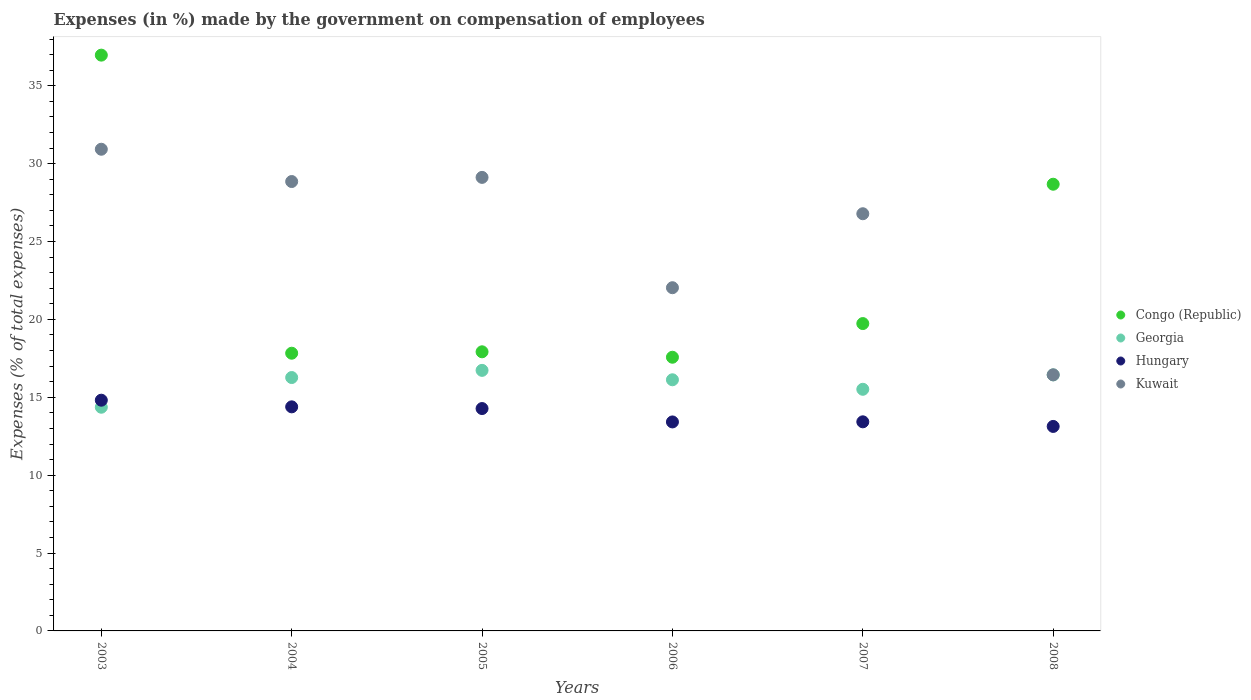Is the number of dotlines equal to the number of legend labels?
Provide a succinct answer. Yes. What is the percentage of expenses made by the government on compensation of employees in Kuwait in 2008?
Provide a short and direct response. 16.44. Across all years, what is the maximum percentage of expenses made by the government on compensation of employees in Congo (Republic)?
Make the answer very short. 36.97. Across all years, what is the minimum percentage of expenses made by the government on compensation of employees in Hungary?
Provide a short and direct response. 13.13. In which year was the percentage of expenses made by the government on compensation of employees in Congo (Republic) maximum?
Make the answer very short. 2003. In which year was the percentage of expenses made by the government on compensation of employees in Congo (Republic) minimum?
Offer a very short reply. 2006. What is the total percentage of expenses made by the government on compensation of employees in Hungary in the graph?
Make the answer very short. 83.45. What is the difference between the percentage of expenses made by the government on compensation of employees in Kuwait in 2004 and that in 2008?
Ensure brevity in your answer.  12.41. What is the difference between the percentage of expenses made by the government on compensation of employees in Congo (Republic) in 2005 and the percentage of expenses made by the government on compensation of employees in Georgia in 2007?
Your answer should be very brief. 2.41. What is the average percentage of expenses made by the government on compensation of employees in Georgia per year?
Offer a very short reply. 15.91. In the year 2007, what is the difference between the percentage of expenses made by the government on compensation of employees in Georgia and percentage of expenses made by the government on compensation of employees in Congo (Republic)?
Keep it short and to the point. -4.22. In how many years, is the percentage of expenses made by the government on compensation of employees in Congo (Republic) greater than 29 %?
Provide a short and direct response. 1. What is the ratio of the percentage of expenses made by the government on compensation of employees in Kuwait in 2005 to that in 2007?
Your answer should be very brief. 1.09. What is the difference between the highest and the second highest percentage of expenses made by the government on compensation of employees in Congo (Republic)?
Ensure brevity in your answer.  8.29. What is the difference between the highest and the lowest percentage of expenses made by the government on compensation of employees in Congo (Republic)?
Offer a very short reply. 19.4. Does the percentage of expenses made by the government on compensation of employees in Kuwait monotonically increase over the years?
Offer a terse response. No. Is the percentage of expenses made by the government on compensation of employees in Hungary strictly greater than the percentage of expenses made by the government on compensation of employees in Kuwait over the years?
Provide a succinct answer. No. How many dotlines are there?
Your response must be concise. 4. Does the graph contain any zero values?
Give a very brief answer. No. Where does the legend appear in the graph?
Make the answer very short. Center right. How are the legend labels stacked?
Your answer should be compact. Vertical. What is the title of the graph?
Keep it short and to the point. Expenses (in %) made by the government on compensation of employees. What is the label or title of the Y-axis?
Give a very brief answer. Expenses (% of total expenses). What is the Expenses (% of total expenses) of Congo (Republic) in 2003?
Your response must be concise. 36.97. What is the Expenses (% of total expenses) of Georgia in 2003?
Offer a terse response. 14.36. What is the Expenses (% of total expenses) in Hungary in 2003?
Ensure brevity in your answer.  14.81. What is the Expenses (% of total expenses) in Kuwait in 2003?
Give a very brief answer. 30.93. What is the Expenses (% of total expenses) in Congo (Republic) in 2004?
Your response must be concise. 17.83. What is the Expenses (% of total expenses) in Georgia in 2004?
Ensure brevity in your answer.  16.27. What is the Expenses (% of total expenses) of Hungary in 2004?
Make the answer very short. 14.39. What is the Expenses (% of total expenses) of Kuwait in 2004?
Your response must be concise. 28.85. What is the Expenses (% of total expenses) of Congo (Republic) in 2005?
Your answer should be very brief. 17.92. What is the Expenses (% of total expenses) of Georgia in 2005?
Give a very brief answer. 16.73. What is the Expenses (% of total expenses) in Hungary in 2005?
Provide a short and direct response. 14.28. What is the Expenses (% of total expenses) in Kuwait in 2005?
Your answer should be compact. 29.12. What is the Expenses (% of total expenses) in Congo (Republic) in 2006?
Provide a short and direct response. 17.57. What is the Expenses (% of total expenses) of Georgia in 2006?
Offer a very short reply. 16.12. What is the Expenses (% of total expenses) in Hungary in 2006?
Offer a very short reply. 13.42. What is the Expenses (% of total expenses) of Kuwait in 2006?
Give a very brief answer. 22.04. What is the Expenses (% of total expenses) in Congo (Republic) in 2007?
Your answer should be very brief. 19.73. What is the Expenses (% of total expenses) of Georgia in 2007?
Keep it short and to the point. 15.51. What is the Expenses (% of total expenses) in Hungary in 2007?
Give a very brief answer. 13.43. What is the Expenses (% of total expenses) in Kuwait in 2007?
Your answer should be very brief. 26.79. What is the Expenses (% of total expenses) of Congo (Republic) in 2008?
Your response must be concise. 28.68. What is the Expenses (% of total expenses) of Georgia in 2008?
Offer a terse response. 16.44. What is the Expenses (% of total expenses) in Hungary in 2008?
Offer a terse response. 13.13. What is the Expenses (% of total expenses) in Kuwait in 2008?
Your answer should be very brief. 16.44. Across all years, what is the maximum Expenses (% of total expenses) in Congo (Republic)?
Your answer should be very brief. 36.97. Across all years, what is the maximum Expenses (% of total expenses) of Georgia?
Offer a very short reply. 16.73. Across all years, what is the maximum Expenses (% of total expenses) of Hungary?
Provide a succinct answer. 14.81. Across all years, what is the maximum Expenses (% of total expenses) of Kuwait?
Offer a very short reply. 30.93. Across all years, what is the minimum Expenses (% of total expenses) in Congo (Republic)?
Provide a short and direct response. 17.57. Across all years, what is the minimum Expenses (% of total expenses) of Georgia?
Provide a succinct answer. 14.36. Across all years, what is the minimum Expenses (% of total expenses) in Hungary?
Your answer should be very brief. 13.13. Across all years, what is the minimum Expenses (% of total expenses) of Kuwait?
Ensure brevity in your answer.  16.44. What is the total Expenses (% of total expenses) of Congo (Republic) in the graph?
Your answer should be very brief. 138.71. What is the total Expenses (% of total expenses) in Georgia in the graph?
Make the answer very short. 95.44. What is the total Expenses (% of total expenses) of Hungary in the graph?
Provide a short and direct response. 83.45. What is the total Expenses (% of total expenses) in Kuwait in the graph?
Provide a succinct answer. 154.16. What is the difference between the Expenses (% of total expenses) in Congo (Republic) in 2003 and that in 2004?
Give a very brief answer. 19.14. What is the difference between the Expenses (% of total expenses) in Georgia in 2003 and that in 2004?
Your response must be concise. -1.91. What is the difference between the Expenses (% of total expenses) in Hungary in 2003 and that in 2004?
Offer a terse response. 0.43. What is the difference between the Expenses (% of total expenses) in Kuwait in 2003 and that in 2004?
Offer a terse response. 2.07. What is the difference between the Expenses (% of total expenses) in Congo (Republic) in 2003 and that in 2005?
Provide a short and direct response. 19.05. What is the difference between the Expenses (% of total expenses) of Georgia in 2003 and that in 2005?
Your answer should be compact. -2.37. What is the difference between the Expenses (% of total expenses) in Hungary in 2003 and that in 2005?
Your answer should be compact. 0.54. What is the difference between the Expenses (% of total expenses) of Kuwait in 2003 and that in 2005?
Your answer should be compact. 1.81. What is the difference between the Expenses (% of total expenses) of Congo (Republic) in 2003 and that in 2006?
Make the answer very short. 19.4. What is the difference between the Expenses (% of total expenses) of Georgia in 2003 and that in 2006?
Your response must be concise. -1.76. What is the difference between the Expenses (% of total expenses) of Hungary in 2003 and that in 2006?
Make the answer very short. 1.4. What is the difference between the Expenses (% of total expenses) in Kuwait in 2003 and that in 2006?
Your answer should be compact. 8.89. What is the difference between the Expenses (% of total expenses) of Congo (Republic) in 2003 and that in 2007?
Ensure brevity in your answer.  17.23. What is the difference between the Expenses (% of total expenses) of Georgia in 2003 and that in 2007?
Make the answer very short. -1.15. What is the difference between the Expenses (% of total expenses) in Hungary in 2003 and that in 2007?
Provide a succinct answer. 1.39. What is the difference between the Expenses (% of total expenses) of Kuwait in 2003 and that in 2007?
Keep it short and to the point. 4.14. What is the difference between the Expenses (% of total expenses) in Congo (Republic) in 2003 and that in 2008?
Your answer should be compact. 8.29. What is the difference between the Expenses (% of total expenses) of Georgia in 2003 and that in 2008?
Keep it short and to the point. -2.08. What is the difference between the Expenses (% of total expenses) in Hungary in 2003 and that in 2008?
Offer a very short reply. 1.68. What is the difference between the Expenses (% of total expenses) of Kuwait in 2003 and that in 2008?
Provide a short and direct response. 14.48. What is the difference between the Expenses (% of total expenses) in Congo (Republic) in 2004 and that in 2005?
Offer a very short reply. -0.09. What is the difference between the Expenses (% of total expenses) of Georgia in 2004 and that in 2005?
Offer a terse response. -0.46. What is the difference between the Expenses (% of total expenses) of Hungary in 2004 and that in 2005?
Keep it short and to the point. 0.11. What is the difference between the Expenses (% of total expenses) in Kuwait in 2004 and that in 2005?
Your answer should be compact. -0.27. What is the difference between the Expenses (% of total expenses) of Congo (Republic) in 2004 and that in 2006?
Provide a succinct answer. 0.26. What is the difference between the Expenses (% of total expenses) of Georgia in 2004 and that in 2006?
Provide a succinct answer. 0.14. What is the difference between the Expenses (% of total expenses) in Hungary in 2004 and that in 2006?
Ensure brevity in your answer.  0.97. What is the difference between the Expenses (% of total expenses) of Kuwait in 2004 and that in 2006?
Provide a succinct answer. 6.82. What is the difference between the Expenses (% of total expenses) of Congo (Republic) in 2004 and that in 2007?
Give a very brief answer. -1.9. What is the difference between the Expenses (% of total expenses) of Georgia in 2004 and that in 2007?
Provide a succinct answer. 0.75. What is the difference between the Expenses (% of total expenses) in Hungary in 2004 and that in 2007?
Your response must be concise. 0.96. What is the difference between the Expenses (% of total expenses) of Kuwait in 2004 and that in 2007?
Provide a short and direct response. 2.07. What is the difference between the Expenses (% of total expenses) of Congo (Republic) in 2004 and that in 2008?
Provide a succinct answer. -10.85. What is the difference between the Expenses (% of total expenses) in Georgia in 2004 and that in 2008?
Make the answer very short. -0.17. What is the difference between the Expenses (% of total expenses) of Hungary in 2004 and that in 2008?
Keep it short and to the point. 1.26. What is the difference between the Expenses (% of total expenses) in Kuwait in 2004 and that in 2008?
Keep it short and to the point. 12.41. What is the difference between the Expenses (% of total expenses) in Congo (Republic) in 2005 and that in 2006?
Your answer should be very brief. 0.35. What is the difference between the Expenses (% of total expenses) in Georgia in 2005 and that in 2006?
Give a very brief answer. 0.6. What is the difference between the Expenses (% of total expenses) of Hungary in 2005 and that in 2006?
Offer a terse response. 0.86. What is the difference between the Expenses (% of total expenses) of Kuwait in 2005 and that in 2006?
Ensure brevity in your answer.  7.08. What is the difference between the Expenses (% of total expenses) in Congo (Republic) in 2005 and that in 2007?
Ensure brevity in your answer.  -1.81. What is the difference between the Expenses (% of total expenses) of Georgia in 2005 and that in 2007?
Give a very brief answer. 1.21. What is the difference between the Expenses (% of total expenses) in Hungary in 2005 and that in 2007?
Your response must be concise. 0.85. What is the difference between the Expenses (% of total expenses) of Kuwait in 2005 and that in 2007?
Your response must be concise. 2.33. What is the difference between the Expenses (% of total expenses) in Congo (Republic) in 2005 and that in 2008?
Ensure brevity in your answer.  -10.76. What is the difference between the Expenses (% of total expenses) of Georgia in 2005 and that in 2008?
Make the answer very short. 0.29. What is the difference between the Expenses (% of total expenses) in Hungary in 2005 and that in 2008?
Keep it short and to the point. 1.15. What is the difference between the Expenses (% of total expenses) in Kuwait in 2005 and that in 2008?
Give a very brief answer. 12.68. What is the difference between the Expenses (% of total expenses) in Congo (Republic) in 2006 and that in 2007?
Keep it short and to the point. -2.16. What is the difference between the Expenses (% of total expenses) of Georgia in 2006 and that in 2007?
Provide a short and direct response. 0.61. What is the difference between the Expenses (% of total expenses) in Hungary in 2006 and that in 2007?
Your response must be concise. -0.01. What is the difference between the Expenses (% of total expenses) in Kuwait in 2006 and that in 2007?
Keep it short and to the point. -4.75. What is the difference between the Expenses (% of total expenses) of Congo (Republic) in 2006 and that in 2008?
Your response must be concise. -11.11. What is the difference between the Expenses (% of total expenses) of Georgia in 2006 and that in 2008?
Your answer should be compact. -0.31. What is the difference between the Expenses (% of total expenses) of Hungary in 2006 and that in 2008?
Offer a terse response. 0.29. What is the difference between the Expenses (% of total expenses) in Kuwait in 2006 and that in 2008?
Your answer should be very brief. 5.59. What is the difference between the Expenses (% of total expenses) of Congo (Republic) in 2007 and that in 2008?
Ensure brevity in your answer.  -8.95. What is the difference between the Expenses (% of total expenses) of Georgia in 2007 and that in 2008?
Ensure brevity in your answer.  -0.92. What is the difference between the Expenses (% of total expenses) in Hungary in 2007 and that in 2008?
Keep it short and to the point. 0.3. What is the difference between the Expenses (% of total expenses) in Kuwait in 2007 and that in 2008?
Give a very brief answer. 10.34. What is the difference between the Expenses (% of total expenses) of Congo (Republic) in 2003 and the Expenses (% of total expenses) of Georgia in 2004?
Offer a terse response. 20.7. What is the difference between the Expenses (% of total expenses) in Congo (Republic) in 2003 and the Expenses (% of total expenses) in Hungary in 2004?
Your answer should be compact. 22.58. What is the difference between the Expenses (% of total expenses) in Congo (Republic) in 2003 and the Expenses (% of total expenses) in Kuwait in 2004?
Your answer should be compact. 8.12. What is the difference between the Expenses (% of total expenses) in Georgia in 2003 and the Expenses (% of total expenses) in Hungary in 2004?
Your answer should be compact. -0.02. What is the difference between the Expenses (% of total expenses) of Georgia in 2003 and the Expenses (% of total expenses) of Kuwait in 2004?
Offer a terse response. -14.49. What is the difference between the Expenses (% of total expenses) in Hungary in 2003 and the Expenses (% of total expenses) in Kuwait in 2004?
Keep it short and to the point. -14.04. What is the difference between the Expenses (% of total expenses) in Congo (Republic) in 2003 and the Expenses (% of total expenses) in Georgia in 2005?
Your answer should be compact. 20.24. What is the difference between the Expenses (% of total expenses) of Congo (Republic) in 2003 and the Expenses (% of total expenses) of Hungary in 2005?
Provide a short and direct response. 22.69. What is the difference between the Expenses (% of total expenses) of Congo (Republic) in 2003 and the Expenses (% of total expenses) of Kuwait in 2005?
Your answer should be very brief. 7.85. What is the difference between the Expenses (% of total expenses) in Georgia in 2003 and the Expenses (% of total expenses) in Hungary in 2005?
Your answer should be very brief. 0.08. What is the difference between the Expenses (% of total expenses) of Georgia in 2003 and the Expenses (% of total expenses) of Kuwait in 2005?
Your answer should be very brief. -14.76. What is the difference between the Expenses (% of total expenses) of Hungary in 2003 and the Expenses (% of total expenses) of Kuwait in 2005?
Ensure brevity in your answer.  -14.31. What is the difference between the Expenses (% of total expenses) of Congo (Republic) in 2003 and the Expenses (% of total expenses) of Georgia in 2006?
Provide a succinct answer. 20.84. What is the difference between the Expenses (% of total expenses) in Congo (Republic) in 2003 and the Expenses (% of total expenses) in Hungary in 2006?
Offer a very short reply. 23.55. What is the difference between the Expenses (% of total expenses) of Congo (Republic) in 2003 and the Expenses (% of total expenses) of Kuwait in 2006?
Keep it short and to the point. 14.93. What is the difference between the Expenses (% of total expenses) of Georgia in 2003 and the Expenses (% of total expenses) of Hungary in 2006?
Give a very brief answer. 0.94. What is the difference between the Expenses (% of total expenses) of Georgia in 2003 and the Expenses (% of total expenses) of Kuwait in 2006?
Your response must be concise. -7.67. What is the difference between the Expenses (% of total expenses) of Hungary in 2003 and the Expenses (% of total expenses) of Kuwait in 2006?
Offer a very short reply. -7.22. What is the difference between the Expenses (% of total expenses) of Congo (Republic) in 2003 and the Expenses (% of total expenses) of Georgia in 2007?
Provide a succinct answer. 21.45. What is the difference between the Expenses (% of total expenses) in Congo (Republic) in 2003 and the Expenses (% of total expenses) in Hungary in 2007?
Provide a short and direct response. 23.54. What is the difference between the Expenses (% of total expenses) in Congo (Republic) in 2003 and the Expenses (% of total expenses) in Kuwait in 2007?
Your response must be concise. 10.18. What is the difference between the Expenses (% of total expenses) of Georgia in 2003 and the Expenses (% of total expenses) of Hungary in 2007?
Ensure brevity in your answer.  0.94. What is the difference between the Expenses (% of total expenses) in Georgia in 2003 and the Expenses (% of total expenses) in Kuwait in 2007?
Your answer should be compact. -12.42. What is the difference between the Expenses (% of total expenses) in Hungary in 2003 and the Expenses (% of total expenses) in Kuwait in 2007?
Offer a terse response. -11.97. What is the difference between the Expenses (% of total expenses) in Congo (Republic) in 2003 and the Expenses (% of total expenses) in Georgia in 2008?
Make the answer very short. 20.53. What is the difference between the Expenses (% of total expenses) in Congo (Republic) in 2003 and the Expenses (% of total expenses) in Hungary in 2008?
Offer a very short reply. 23.84. What is the difference between the Expenses (% of total expenses) of Congo (Republic) in 2003 and the Expenses (% of total expenses) of Kuwait in 2008?
Your answer should be very brief. 20.53. What is the difference between the Expenses (% of total expenses) of Georgia in 2003 and the Expenses (% of total expenses) of Hungary in 2008?
Keep it short and to the point. 1.23. What is the difference between the Expenses (% of total expenses) of Georgia in 2003 and the Expenses (% of total expenses) of Kuwait in 2008?
Offer a terse response. -2.08. What is the difference between the Expenses (% of total expenses) in Hungary in 2003 and the Expenses (% of total expenses) in Kuwait in 2008?
Your answer should be compact. -1.63. What is the difference between the Expenses (% of total expenses) in Congo (Republic) in 2004 and the Expenses (% of total expenses) in Georgia in 2005?
Offer a terse response. 1.1. What is the difference between the Expenses (% of total expenses) of Congo (Republic) in 2004 and the Expenses (% of total expenses) of Hungary in 2005?
Your answer should be compact. 3.55. What is the difference between the Expenses (% of total expenses) in Congo (Republic) in 2004 and the Expenses (% of total expenses) in Kuwait in 2005?
Keep it short and to the point. -11.29. What is the difference between the Expenses (% of total expenses) of Georgia in 2004 and the Expenses (% of total expenses) of Hungary in 2005?
Keep it short and to the point. 1.99. What is the difference between the Expenses (% of total expenses) of Georgia in 2004 and the Expenses (% of total expenses) of Kuwait in 2005?
Your answer should be very brief. -12.85. What is the difference between the Expenses (% of total expenses) of Hungary in 2004 and the Expenses (% of total expenses) of Kuwait in 2005?
Make the answer very short. -14.73. What is the difference between the Expenses (% of total expenses) of Congo (Republic) in 2004 and the Expenses (% of total expenses) of Georgia in 2006?
Offer a very short reply. 1.71. What is the difference between the Expenses (% of total expenses) in Congo (Republic) in 2004 and the Expenses (% of total expenses) in Hungary in 2006?
Ensure brevity in your answer.  4.41. What is the difference between the Expenses (% of total expenses) in Congo (Republic) in 2004 and the Expenses (% of total expenses) in Kuwait in 2006?
Provide a short and direct response. -4.21. What is the difference between the Expenses (% of total expenses) in Georgia in 2004 and the Expenses (% of total expenses) in Hungary in 2006?
Offer a terse response. 2.85. What is the difference between the Expenses (% of total expenses) in Georgia in 2004 and the Expenses (% of total expenses) in Kuwait in 2006?
Give a very brief answer. -5.77. What is the difference between the Expenses (% of total expenses) in Hungary in 2004 and the Expenses (% of total expenses) in Kuwait in 2006?
Make the answer very short. -7.65. What is the difference between the Expenses (% of total expenses) in Congo (Republic) in 2004 and the Expenses (% of total expenses) in Georgia in 2007?
Your response must be concise. 2.32. What is the difference between the Expenses (% of total expenses) of Congo (Republic) in 2004 and the Expenses (% of total expenses) of Hungary in 2007?
Offer a very short reply. 4.4. What is the difference between the Expenses (% of total expenses) of Congo (Republic) in 2004 and the Expenses (% of total expenses) of Kuwait in 2007?
Keep it short and to the point. -8.96. What is the difference between the Expenses (% of total expenses) of Georgia in 2004 and the Expenses (% of total expenses) of Hungary in 2007?
Provide a succinct answer. 2.84. What is the difference between the Expenses (% of total expenses) in Georgia in 2004 and the Expenses (% of total expenses) in Kuwait in 2007?
Provide a short and direct response. -10.52. What is the difference between the Expenses (% of total expenses) of Hungary in 2004 and the Expenses (% of total expenses) of Kuwait in 2007?
Keep it short and to the point. -12.4. What is the difference between the Expenses (% of total expenses) of Congo (Republic) in 2004 and the Expenses (% of total expenses) of Georgia in 2008?
Your answer should be very brief. 1.39. What is the difference between the Expenses (% of total expenses) in Congo (Republic) in 2004 and the Expenses (% of total expenses) in Hungary in 2008?
Offer a terse response. 4.7. What is the difference between the Expenses (% of total expenses) of Congo (Republic) in 2004 and the Expenses (% of total expenses) of Kuwait in 2008?
Provide a succinct answer. 1.39. What is the difference between the Expenses (% of total expenses) in Georgia in 2004 and the Expenses (% of total expenses) in Hungary in 2008?
Keep it short and to the point. 3.14. What is the difference between the Expenses (% of total expenses) of Georgia in 2004 and the Expenses (% of total expenses) of Kuwait in 2008?
Offer a terse response. -0.17. What is the difference between the Expenses (% of total expenses) in Hungary in 2004 and the Expenses (% of total expenses) in Kuwait in 2008?
Your answer should be very brief. -2.06. What is the difference between the Expenses (% of total expenses) in Congo (Republic) in 2005 and the Expenses (% of total expenses) in Georgia in 2006?
Your response must be concise. 1.8. What is the difference between the Expenses (% of total expenses) in Congo (Republic) in 2005 and the Expenses (% of total expenses) in Hungary in 2006?
Provide a succinct answer. 4.5. What is the difference between the Expenses (% of total expenses) of Congo (Republic) in 2005 and the Expenses (% of total expenses) of Kuwait in 2006?
Give a very brief answer. -4.11. What is the difference between the Expenses (% of total expenses) of Georgia in 2005 and the Expenses (% of total expenses) of Hungary in 2006?
Keep it short and to the point. 3.31. What is the difference between the Expenses (% of total expenses) in Georgia in 2005 and the Expenses (% of total expenses) in Kuwait in 2006?
Your response must be concise. -5.31. What is the difference between the Expenses (% of total expenses) in Hungary in 2005 and the Expenses (% of total expenses) in Kuwait in 2006?
Provide a succinct answer. -7.76. What is the difference between the Expenses (% of total expenses) of Congo (Republic) in 2005 and the Expenses (% of total expenses) of Georgia in 2007?
Provide a short and direct response. 2.41. What is the difference between the Expenses (% of total expenses) of Congo (Republic) in 2005 and the Expenses (% of total expenses) of Hungary in 2007?
Give a very brief answer. 4.5. What is the difference between the Expenses (% of total expenses) of Congo (Republic) in 2005 and the Expenses (% of total expenses) of Kuwait in 2007?
Your response must be concise. -8.86. What is the difference between the Expenses (% of total expenses) in Georgia in 2005 and the Expenses (% of total expenses) in Hungary in 2007?
Ensure brevity in your answer.  3.3. What is the difference between the Expenses (% of total expenses) of Georgia in 2005 and the Expenses (% of total expenses) of Kuwait in 2007?
Offer a very short reply. -10.06. What is the difference between the Expenses (% of total expenses) in Hungary in 2005 and the Expenses (% of total expenses) in Kuwait in 2007?
Your answer should be very brief. -12.51. What is the difference between the Expenses (% of total expenses) in Congo (Republic) in 2005 and the Expenses (% of total expenses) in Georgia in 2008?
Give a very brief answer. 1.48. What is the difference between the Expenses (% of total expenses) in Congo (Republic) in 2005 and the Expenses (% of total expenses) in Hungary in 2008?
Ensure brevity in your answer.  4.79. What is the difference between the Expenses (% of total expenses) of Congo (Republic) in 2005 and the Expenses (% of total expenses) of Kuwait in 2008?
Offer a very short reply. 1.48. What is the difference between the Expenses (% of total expenses) of Georgia in 2005 and the Expenses (% of total expenses) of Hungary in 2008?
Your response must be concise. 3.6. What is the difference between the Expenses (% of total expenses) of Georgia in 2005 and the Expenses (% of total expenses) of Kuwait in 2008?
Offer a very short reply. 0.29. What is the difference between the Expenses (% of total expenses) in Hungary in 2005 and the Expenses (% of total expenses) in Kuwait in 2008?
Your response must be concise. -2.17. What is the difference between the Expenses (% of total expenses) of Congo (Republic) in 2006 and the Expenses (% of total expenses) of Georgia in 2007?
Keep it short and to the point. 2.06. What is the difference between the Expenses (% of total expenses) in Congo (Republic) in 2006 and the Expenses (% of total expenses) in Hungary in 2007?
Your response must be concise. 4.15. What is the difference between the Expenses (% of total expenses) of Congo (Republic) in 2006 and the Expenses (% of total expenses) of Kuwait in 2007?
Your answer should be very brief. -9.21. What is the difference between the Expenses (% of total expenses) of Georgia in 2006 and the Expenses (% of total expenses) of Hungary in 2007?
Offer a terse response. 2.7. What is the difference between the Expenses (% of total expenses) in Georgia in 2006 and the Expenses (% of total expenses) in Kuwait in 2007?
Offer a terse response. -10.66. What is the difference between the Expenses (% of total expenses) of Hungary in 2006 and the Expenses (% of total expenses) of Kuwait in 2007?
Give a very brief answer. -13.37. What is the difference between the Expenses (% of total expenses) in Congo (Republic) in 2006 and the Expenses (% of total expenses) in Georgia in 2008?
Ensure brevity in your answer.  1.13. What is the difference between the Expenses (% of total expenses) in Congo (Republic) in 2006 and the Expenses (% of total expenses) in Hungary in 2008?
Give a very brief answer. 4.44. What is the difference between the Expenses (% of total expenses) of Congo (Republic) in 2006 and the Expenses (% of total expenses) of Kuwait in 2008?
Your answer should be very brief. 1.13. What is the difference between the Expenses (% of total expenses) of Georgia in 2006 and the Expenses (% of total expenses) of Hungary in 2008?
Ensure brevity in your answer.  2.99. What is the difference between the Expenses (% of total expenses) in Georgia in 2006 and the Expenses (% of total expenses) in Kuwait in 2008?
Make the answer very short. -0.32. What is the difference between the Expenses (% of total expenses) in Hungary in 2006 and the Expenses (% of total expenses) in Kuwait in 2008?
Offer a terse response. -3.03. What is the difference between the Expenses (% of total expenses) in Congo (Republic) in 2007 and the Expenses (% of total expenses) in Georgia in 2008?
Provide a short and direct response. 3.3. What is the difference between the Expenses (% of total expenses) of Congo (Republic) in 2007 and the Expenses (% of total expenses) of Hungary in 2008?
Offer a very short reply. 6.6. What is the difference between the Expenses (% of total expenses) in Congo (Republic) in 2007 and the Expenses (% of total expenses) in Kuwait in 2008?
Provide a short and direct response. 3.29. What is the difference between the Expenses (% of total expenses) of Georgia in 2007 and the Expenses (% of total expenses) of Hungary in 2008?
Keep it short and to the point. 2.38. What is the difference between the Expenses (% of total expenses) of Georgia in 2007 and the Expenses (% of total expenses) of Kuwait in 2008?
Give a very brief answer. -0.93. What is the difference between the Expenses (% of total expenses) in Hungary in 2007 and the Expenses (% of total expenses) in Kuwait in 2008?
Give a very brief answer. -3.02. What is the average Expenses (% of total expenses) in Congo (Republic) per year?
Your answer should be very brief. 23.12. What is the average Expenses (% of total expenses) in Georgia per year?
Provide a succinct answer. 15.91. What is the average Expenses (% of total expenses) of Hungary per year?
Keep it short and to the point. 13.91. What is the average Expenses (% of total expenses) of Kuwait per year?
Provide a short and direct response. 25.69. In the year 2003, what is the difference between the Expenses (% of total expenses) in Congo (Republic) and Expenses (% of total expenses) in Georgia?
Your answer should be very brief. 22.61. In the year 2003, what is the difference between the Expenses (% of total expenses) of Congo (Republic) and Expenses (% of total expenses) of Hungary?
Give a very brief answer. 22.15. In the year 2003, what is the difference between the Expenses (% of total expenses) in Congo (Republic) and Expenses (% of total expenses) in Kuwait?
Keep it short and to the point. 6.04. In the year 2003, what is the difference between the Expenses (% of total expenses) in Georgia and Expenses (% of total expenses) in Hungary?
Your answer should be compact. -0.45. In the year 2003, what is the difference between the Expenses (% of total expenses) of Georgia and Expenses (% of total expenses) of Kuwait?
Offer a very short reply. -16.56. In the year 2003, what is the difference between the Expenses (% of total expenses) of Hungary and Expenses (% of total expenses) of Kuwait?
Your answer should be compact. -16.11. In the year 2004, what is the difference between the Expenses (% of total expenses) of Congo (Republic) and Expenses (% of total expenses) of Georgia?
Provide a short and direct response. 1.56. In the year 2004, what is the difference between the Expenses (% of total expenses) of Congo (Republic) and Expenses (% of total expenses) of Hungary?
Provide a succinct answer. 3.44. In the year 2004, what is the difference between the Expenses (% of total expenses) in Congo (Republic) and Expenses (% of total expenses) in Kuwait?
Ensure brevity in your answer.  -11.02. In the year 2004, what is the difference between the Expenses (% of total expenses) in Georgia and Expenses (% of total expenses) in Hungary?
Your answer should be compact. 1.88. In the year 2004, what is the difference between the Expenses (% of total expenses) in Georgia and Expenses (% of total expenses) in Kuwait?
Keep it short and to the point. -12.58. In the year 2004, what is the difference between the Expenses (% of total expenses) in Hungary and Expenses (% of total expenses) in Kuwait?
Your response must be concise. -14.47. In the year 2005, what is the difference between the Expenses (% of total expenses) in Congo (Republic) and Expenses (% of total expenses) in Georgia?
Ensure brevity in your answer.  1.19. In the year 2005, what is the difference between the Expenses (% of total expenses) of Congo (Republic) and Expenses (% of total expenses) of Hungary?
Make the answer very short. 3.64. In the year 2005, what is the difference between the Expenses (% of total expenses) of Congo (Republic) and Expenses (% of total expenses) of Kuwait?
Your response must be concise. -11.2. In the year 2005, what is the difference between the Expenses (% of total expenses) of Georgia and Expenses (% of total expenses) of Hungary?
Provide a short and direct response. 2.45. In the year 2005, what is the difference between the Expenses (% of total expenses) of Georgia and Expenses (% of total expenses) of Kuwait?
Provide a short and direct response. -12.39. In the year 2005, what is the difference between the Expenses (% of total expenses) in Hungary and Expenses (% of total expenses) in Kuwait?
Your answer should be compact. -14.84. In the year 2006, what is the difference between the Expenses (% of total expenses) in Congo (Republic) and Expenses (% of total expenses) in Georgia?
Keep it short and to the point. 1.45. In the year 2006, what is the difference between the Expenses (% of total expenses) in Congo (Republic) and Expenses (% of total expenses) in Hungary?
Provide a short and direct response. 4.15. In the year 2006, what is the difference between the Expenses (% of total expenses) of Congo (Republic) and Expenses (% of total expenses) of Kuwait?
Give a very brief answer. -4.46. In the year 2006, what is the difference between the Expenses (% of total expenses) in Georgia and Expenses (% of total expenses) in Hungary?
Ensure brevity in your answer.  2.71. In the year 2006, what is the difference between the Expenses (% of total expenses) in Georgia and Expenses (% of total expenses) in Kuwait?
Provide a succinct answer. -5.91. In the year 2006, what is the difference between the Expenses (% of total expenses) in Hungary and Expenses (% of total expenses) in Kuwait?
Keep it short and to the point. -8.62. In the year 2007, what is the difference between the Expenses (% of total expenses) of Congo (Republic) and Expenses (% of total expenses) of Georgia?
Give a very brief answer. 4.22. In the year 2007, what is the difference between the Expenses (% of total expenses) in Congo (Republic) and Expenses (% of total expenses) in Hungary?
Your answer should be very brief. 6.31. In the year 2007, what is the difference between the Expenses (% of total expenses) in Congo (Republic) and Expenses (% of total expenses) in Kuwait?
Give a very brief answer. -7.05. In the year 2007, what is the difference between the Expenses (% of total expenses) in Georgia and Expenses (% of total expenses) in Hungary?
Keep it short and to the point. 2.09. In the year 2007, what is the difference between the Expenses (% of total expenses) in Georgia and Expenses (% of total expenses) in Kuwait?
Your answer should be very brief. -11.27. In the year 2007, what is the difference between the Expenses (% of total expenses) of Hungary and Expenses (% of total expenses) of Kuwait?
Provide a short and direct response. -13.36. In the year 2008, what is the difference between the Expenses (% of total expenses) in Congo (Republic) and Expenses (% of total expenses) in Georgia?
Offer a terse response. 12.24. In the year 2008, what is the difference between the Expenses (% of total expenses) of Congo (Republic) and Expenses (% of total expenses) of Hungary?
Your answer should be compact. 15.55. In the year 2008, what is the difference between the Expenses (% of total expenses) of Congo (Republic) and Expenses (% of total expenses) of Kuwait?
Provide a succinct answer. 12.24. In the year 2008, what is the difference between the Expenses (% of total expenses) of Georgia and Expenses (% of total expenses) of Hungary?
Your answer should be very brief. 3.31. In the year 2008, what is the difference between the Expenses (% of total expenses) in Georgia and Expenses (% of total expenses) in Kuwait?
Ensure brevity in your answer.  -0. In the year 2008, what is the difference between the Expenses (% of total expenses) in Hungary and Expenses (% of total expenses) in Kuwait?
Make the answer very short. -3.31. What is the ratio of the Expenses (% of total expenses) of Congo (Republic) in 2003 to that in 2004?
Provide a short and direct response. 2.07. What is the ratio of the Expenses (% of total expenses) of Georgia in 2003 to that in 2004?
Give a very brief answer. 0.88. What is the ratio of the Expenses (% of total expenses) of Hungary in 2003 to that in 2004?
Your answer should be compact. 1.03. What is the ratio of the Expenses (% of total expenses) of Kuwait in 2003 to that in 2004?
Provide a succinct answer. 1.07. What is the ratio of the Expenses (% of total expenses) of Congo (Republic) in 2003 to that in 2005?
Offer a very short reply. 2.06. What is the ratio of the Expenses (% of total expenses) in Georgia in 2003 to that in 2005?
Ensure brevity in your answer.  0.86. What is the ratio of the Expenses (% of total expenses) of Hungary in 2003 to that in 2005?
Give a very brief answer. 1.04. What is the ratio of the Expenses (% of total expenses) in Kuwait in 2003 to that in 2005?
Provide a succinct answer. 1.06. What is the ratio of the Expenses (% of total expenses) of Congo (Republic) in 2003 to that in 2006?
Offer a terse response. 2.1. What is the ratio of the Expenses (% of total expenses) of Georgia in 2003 to that in 2006?
Provide a succinct answer. 0.89. What is the ratio of the Expenses (% of total expenses) of Hungary in 2003 to that in 2006?
Your answer should be very brief. 1.1. What is the ratio of the Expenses (% of total expenses) in Kuwait in 2003 to that in 2006?
Give a very brief answer. 1.4. What is the ratio of the Expenses (% of total expenses) in Congo (Republic) in 2003 to that in 2007?
Your response must be concise. 1.87. What is the ratio of the Expenses (% of total expenses) of Georgia in 2003 to that in 2007?
Offer a very short reply. 0.93. What is the ratio of the Expenses (% of total expenses) in Hungary in 2003 to that in 2007?
Your response must be concise. 1.1. What is the ratio of the Expenses (% of total expenses) in Kuwait in 2003 to that in 2007?
Offer a terse response. 1.15. What is the ratio of the Expenses (% of total expenses) in Congo (Republic) in 2003 to that in 2008?
Your response must be concise. 1.29. What is the ratio of the Expenses (% of total expenses) of Georgia in 2003 to that in 2008?
Provide a succinct answer. 0.87. What is the ratio of the Expenses (% of total expenses) of Hungary in 2003 to that in 2008?
Ensure brevity in your answer.  1.13. What is the ratio of the Expenses (% of total expenses) of Kuwait in 2003 to that in 2008?
Your answer should be compact. 1.88. What is the ratio of the Expenses (% of total expenses) in Georgia in 2004 to that in 2005?
Provide a short and direct response. 0.97. What is the ratio of the Expenses (% of total expenses) of Hungary in 2004 to that in 2005?
Ensure brevity in your answer.  1.01. What is the ratio of the Expenses (% of total expenses) in Kuwait in 2004 to that in 2005?
Your response must be concise. 0.99. What is the ratio of the Expenses (% of total expenses) of Congo (Republic) in 2004 to that in 2006?
Ensure brevity in your answer.  1.01. What is the ratio of the Expenses (% of total expenses) of Georgia in 2004 to that in 2006?
Make the answer very short. 1.01. What is the ratio of the Expenses (% of total expenses) of Hungary in 2004 to that in 2006?
Offer a very short reply. 1.07. What is the ratio of the Expenses (% of total expenses) of Kuwait in 2004 to that in 2006?
Offer a very short reply. 1.31. What is the ratio of the Expenses (% of total expenses) of Congo (Republic) in 2004 to that in 2007?
Your response must be concise. 0.9. What is the ratio of the Expenses (% of total expenses) in Georgia in 2004 to that in 2007?
Offer a terse response. 1.05. What is the ratio of the Expenses (% of total expenses) in Hungary in 2004 to that in 2007?
Provide a short and direct response. 1.07. What is the ratio of the Expenses (% of total expenses) of Kuwait in 2004 to that in 2007?
Provide a succinct answer. 1.08. What is the ratio of the Expenses (% of total expenses) of Congo (Republic) in 2004 to that in 2008?
Your response must be concise. 0.62. What is the ratio of the Expenses (% of total expenses) of Georgia in 2004 to that in 2008?
Offer a very short reply. 0.99. What is the ratio of the Expenses (% of total expenses) of Hungary in 2004 to that in 2008?
Provide a succinct answer. 1.1. What is the ratio of the Expenses (% of total expenses) in Kuwait in 2004 to that in 2008?
Provide a succinct answer. 1.75. What is the ratio of the Expenses (% of total expenses) of Congo (Republic) in 2005 to that in 2006?
Offer a terse response. 1.02. What is the ratio of the Expenses (% of total expenses) of Georgia in 2005 to that in 2006?
Keep it short and to the point. 1.04. What is the ratio of the Expenses (% of total expenses) of Hungary in 2005 to that in 2006?
Provide a short and direct response. 1.06. What is the ratio of the Expenses (% of total expenses) of Kuwait in 2005 to that in 2006?
Make the answer very short. 1.32. What is the ratio of the Expenses (% of total expenses) in Congo (Republic) in 2005 to that in 2007?
Provide a succinct answer. 0.91. What is the ratio of the Expenses (% of total expenses) of Georgia in 2005 to that in 2007?
Your answer should be compact. 1.08. What is the ratio of the Expenses (% of total expenses) in Hungary in 2005 to that in 2007?
Make the answer very short. 1.06. What is the ratio of the Expenses (% of total expenses) of Kuwait in 2005 to that in 2007?
Keep it short and to the point. 1.09. What is the ratio of the Expenses (% of total expenses) of Congo (Republic) in 2005 to that in 2008?
Your response must be concise. 0.62. What is the ratio of the Expenses (% of total expenses) of Georgia in 2005 to that in 2008?
Offer a terse response. 1.02. What is the ratio of the Expenses (% of total expenses) of Hungary in 2005 to that in 2008?
Provide a short and direct response. 1.09. What is the ratio of the Expenses (% of total expenses) in Kuwait in 2005 to that in 2008?
Keep it short and to the point. 1.77. What is the ratio of the Expenses (% of total expenses) of Congo (Republic) in 2006 to that in 2007?
Give a very brief answer. 0.89. What is the ratio of the Expenses (% of total expenses) of Georgia in 2006 to that in 2007?
Provide a short and direct response. 1.04. What is the ratio of the Expenses (% of total expenses) in Kuwait in 2006 to that in 2007?
Provide a short and direct response. 0.82. What is the ratio of the Expenses (% of total expenses) of Congo (Republic) in 2006 to that in 2008?
Offer a very short reply. 0.61. What is the ratio of the Expenses (% of total expenses) of Georgia in 2006 to that in 2008?
Provide a succinct answer. 0.98. What is the ratio of the Expenses (% of total expenses) of Hungary in 2006 to that in 2008?
Offer a very short reply. 1.02. What is the ratio of the Expenses (% of total expenses) in Kuwait in 2006 to that in 2008?
Give a very brief answer. 1.34. What is the ratio of the Expenses (% of total expenses) in Congo (Republic) in 2007 to that in 2008?
Provide a short and direct response. 0.69. What is the ratio of the Expenses (% of total expenses) of Georgia in 2007 to that in 2008?
Offer a very short reply. 0.94. What is the ratio of the Expenses (% of total expenses) in Hungary in 2007 to that in 2008?
Ensure brevity in your answer.  1.02. What is the ratio of the Expenses (% of total expenses) of Kuwait in 2007 to that in 2008?
Your answer should be compact. 1.63. What is the difference between the highest and the second highest Expenses (% of total expenses) of Congo (Republic)?
Provide a short and direct response. 8.29. What is the difference between the highest and the second highest Expenses (% of total expenses) in Georgia?
Give a very brief answer. 0.29. What is the difference between the highest and the second highest Expenses (% of total expenses) in Hungary?
Offer a terse response. 0.43. What is the difference between the highest and the second highest Expenses (% of total expenses) in Kuwait?
Offer a terse response. 1.81. What is the difference between the highest and the lowest Expenses (% of total expenses) of Congo (Republic)?
Your answer should be compact. 19.4. What is the difference between the highest and the lowest Expenses (% of total expenses) in Georgia?
Keep it short and to the point. 2.37. What is the difference between the highest and the lowest Expenses (% of total expenses) in Hungary?
Ensure brevity in your answer.  1.68. What is the difference between the highest and the lowest Expenses (% of total expenses) of Kuwait?
Keep it short and to the point. 14.48. 